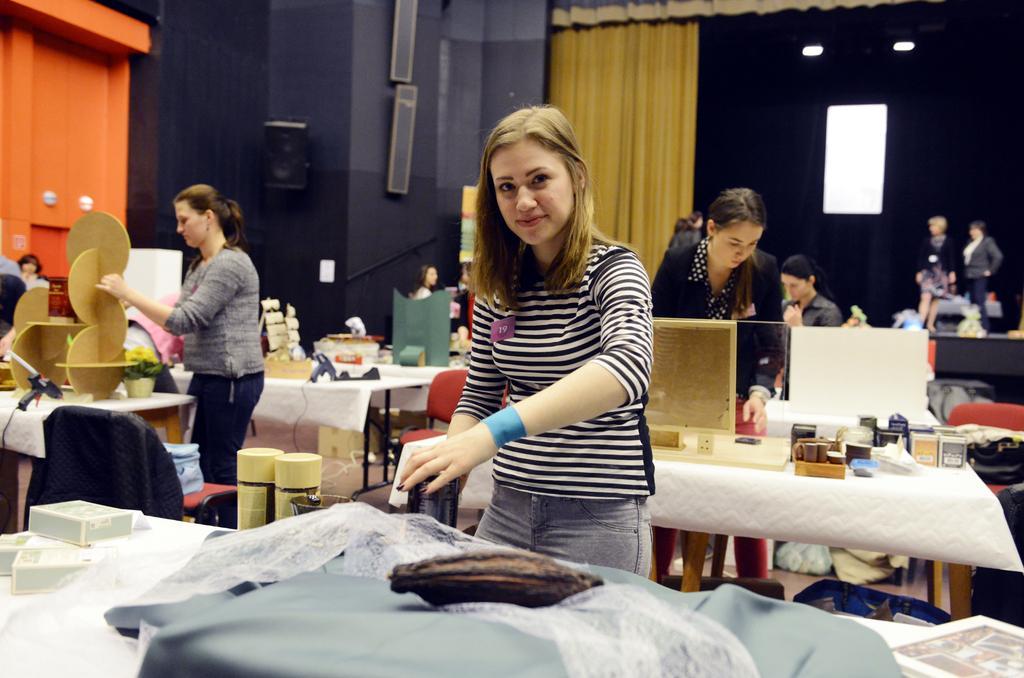Describe this image in one or two sentences. In this image I can see number of people are standing. Here I can see a smile on her face. I can also see few tables and on these tables I can see clothes and few more stuffs. In the background I can see a curtain. 